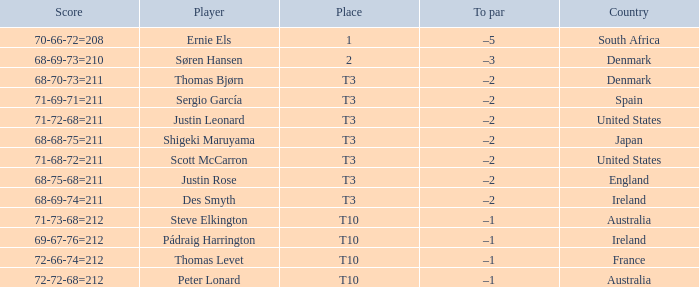What was the place when the score was 71-69-71=211? T3. 